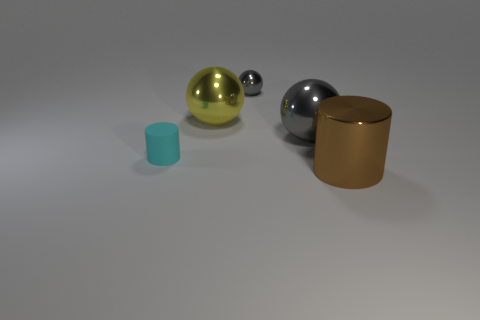The brown metallic cylinder is what size?
Offer a very short reply. Large. There is a big metallic sphere that is to the right of the yellow thing; is its color the same as the small metallic object?
Your answer should be very brief. Yes. What is the size of the cylinder that is on the left side of the cylinder that is in front of the small cyan rubber cylinder?
Ensure brevity in your answer.  Small. There is a yellow object that is the same size as the brown metal cylinder; what is its material?
Ensure brevity in your answer.  Metal. What number of other things are the same size as the brown cylinder?
Make the answer very short. 2. How many blocks are cyan things or large gray objects?
Make the answer very short. 0. Are there any other things that have the same material as the tiny cyan object?
Give a very brief answer. No. What material is the gray sphere right of the tiny thing behind the cylinder to the left of the large cylinder made of?
Your answer should be compact. Metal. How many large cyan cubes have the same material as the big yellow sphere?
Provide a succinct answer. 0. Is the size of the cylinder behind the brown shiny cylinder the same as the tiny gray metal thing?
Offer a very short reply. Yes. 